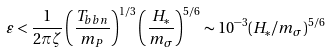<formula> <loc_0><loc_0><loc_500><loc_500>\varepsilon < \frac { 1 } { 2 \pi \zeta } \left ( \frac { T _ { b b n } } { m _ { P } } \right ) ^ { 1 / 3 } \left ( \frac { H _ { * } } { m _ { \sigma } } \right ) ^ { 5 / 6 } \sim 1 0 ^ { - 3 } ( H _ { * } / m _ { \sigma } ) ^ { 5 / 6 }</formula> 